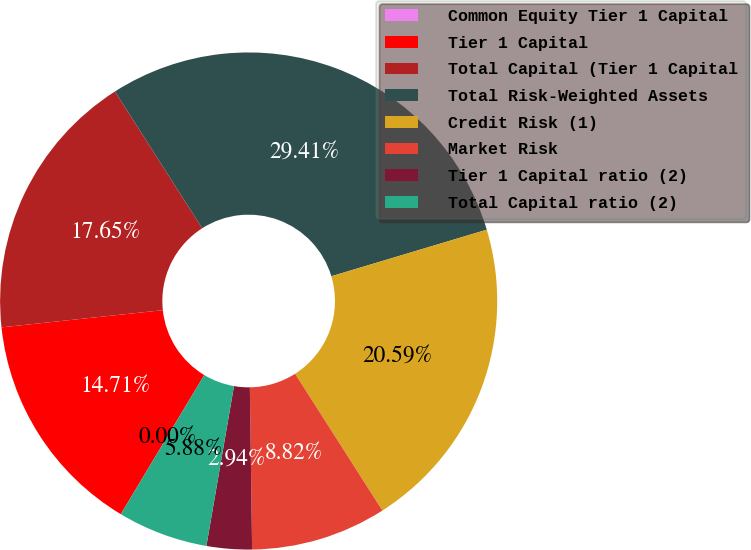Convert chart. <chart><loc_0><loc_0><loc_500><loc_500><pie_chart><fcel>Common Equity Tier 1 Capital<fcel>Tier 1 Capital<fcel>Total Capital (Tier 1 Capital<fcel>Total Risk-Weighted Assets<fcel>Credit Risk (1)<fcel>Market Risk<fcel>Tier 1 Capital ratio (2)<fcel>Total Capital ratio (2)<nl><fcel>0.0%<fcel>14.71%<fcel>17.65%<fcel>29.41%<fcel>20.59%<fcel>8.82%<fcel>2.94%<fcel>5.88%<nl></chart> 